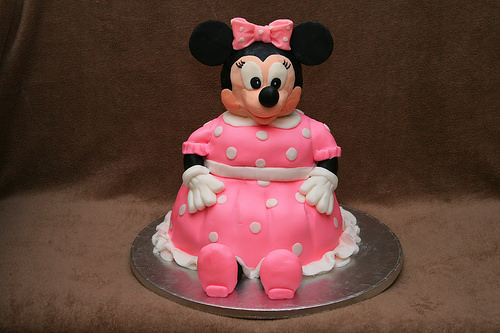<image>
Is there a cake under the dress? No. The cake is not positioned under the dress. The vertical relationship between these objects is different. 